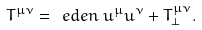<formula> <loc_0><loc_0><loc_500><loc_500>T ^ { \mu \nu } = \ e d e n \, u ^ { \mu } u ^ { \nu } + T ^ { \mu \nu } _ { \perp } .</formula> 